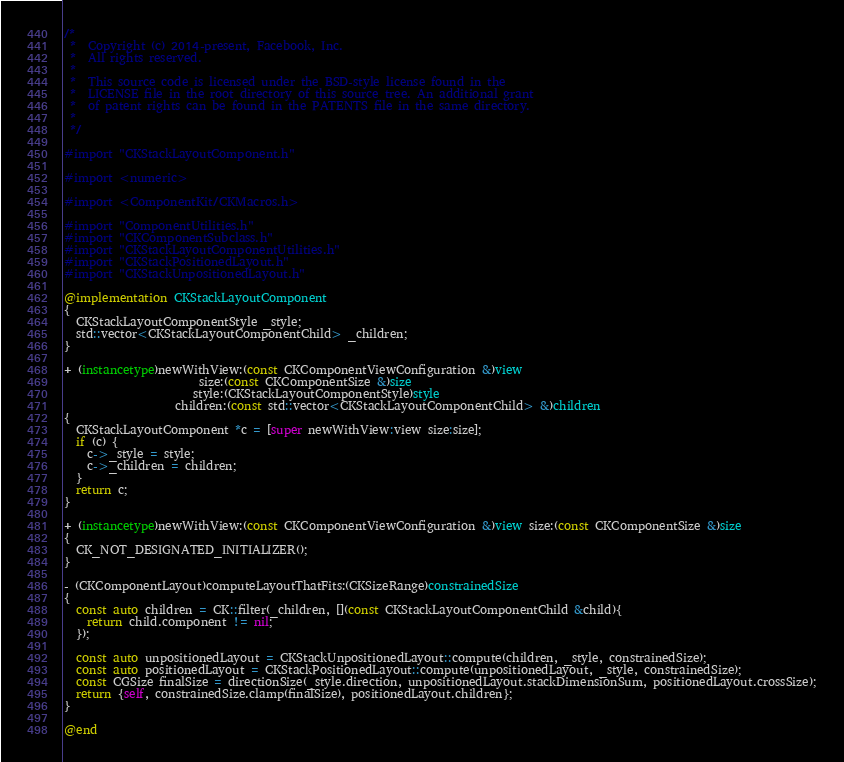Convert code to text. <code><loc_0><loc_0><loc_500><loc_500><_ObjectiveC_>/*
 *  Copyright (c) 2014-present, Facebook, Inc.
 *  All rights reserved.
 *
 *  This source code is licensed under the BSD-style license found in the
 *  LICENSE file in the root directory of this source tree. An additional grant
 *  of patent rights can be found in the PATENTS file in the same directory.
 *
 */

#import "CKStackLayoutComponent.h"

#import <numeric>

#import <ComponentKit/CKMacros.h>

#import "ComponentUtilities.h"
#import "CKComponentSubclass.h"
#import "CKStackLayoutComponentUtilities.h"
#import "CKStackPositionedLayout.h"
#import "CKStackUnpositionedLayout.h"

@implementation CKStackLayoutComponent
{
  CKStackLayoutComponentStyle _style;
  std::vector<CKStackLayoutComponentChild> _children;
}

+ (instancetype)newWithView:(const CKComponentViewConfiguration &)view
                       size:(const CKComponentSize &)size
                      style:(CKStackLayoutComponentStyle)style
                   children:(const std::vector<CKStackLayoutComponentChild> &)children
{
  CKStackLayoutComponent *c = [super newWithView:view size:size];
  if (c) {
    c->_style = style;
    c->_children = children;
  }
  return c;
}

+ (instancetype)newWithView:(const CKComponentViewConfiguration &)view size:(const CKComponentSize &)size
{
  CK_NOT_DESIGNATED_INITIALIZER();
}

- (CKComponentLayout)computeLayoutThatFits:(CKSizeRange)constrainedSize
{
  const auto children = CK::filter(_children, [](const CKStackLayoutComponentChild &child){
    return child.component != nil;
  });

  const auto unpositionedLayout = CKStackUnpositionedLayout::compute(children, _style, constrainedSize);
  const auto positionedLayout = CKStackPositionedLayout::compute(unpositionedLayout, _style, constrainedSize);
  const CGSize finalSize = directionSize(_style.direction, unpositionedLayout.stackDimensionSum, positionedLayout.crossSize);
  return {self, constrainedSize.clamp(finalSize), positionedLayout.children};
}

@end
</code> 